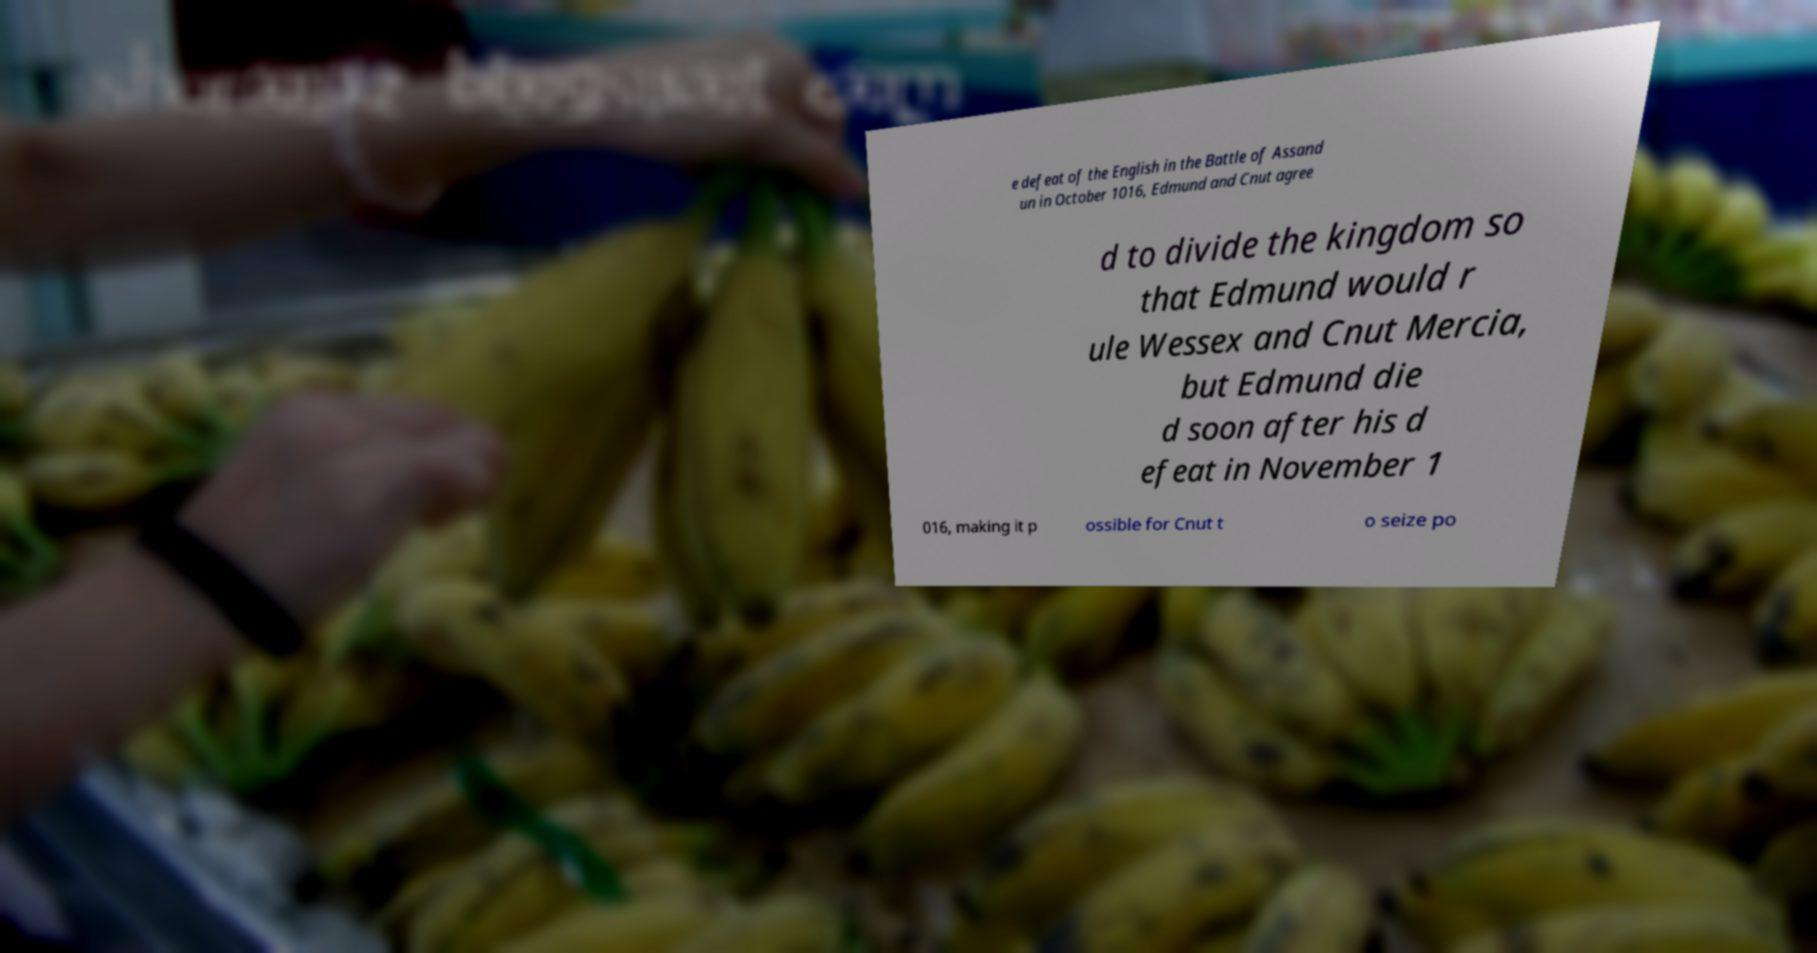Can you accurately transcribe the text from the provided image for me? e defeat of the English in the Battle of Assand un in October 1016, Edmund and Cnut agree d to divide the kingdom so that Edmund would r ule Wessex and Cnut Mercia, but Edmund die d soon after his d efeat in November 1 016, making it p ossible for Cnut t o seize po 